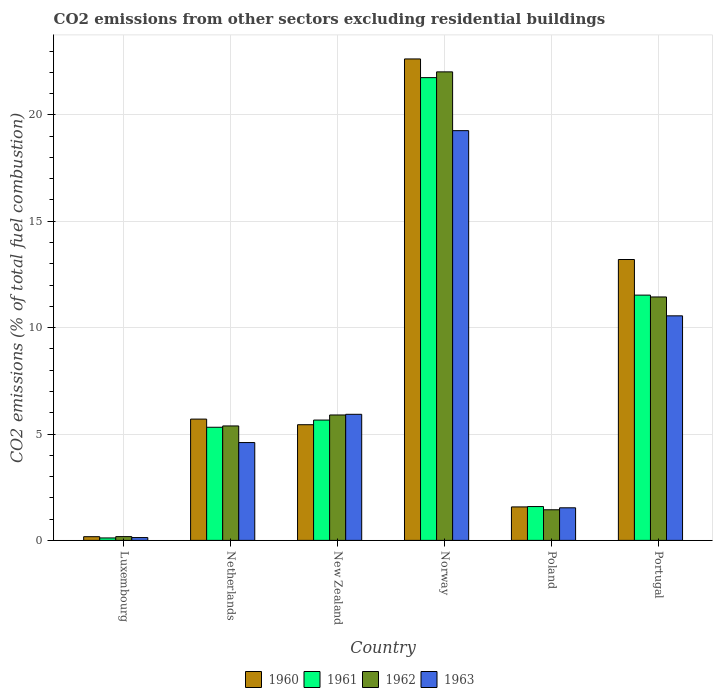How many groups of bars are there?
Keep it short and to the point. 6. Are the number of bars on each tick of the X-axis equal?
Your answer should be very brief. Yes. How many bars are there on the 3rd tick from the left?
Keep it short and to the point. 4. How many bars are there on the 6th tick from the right?
Keep it short and to the point. 4. What is the label of the 2nd group of bars from the left?
Your response must be concise. Netherlands. In how many cases, is the number of bars for a given country not equal to the number of legend labels?
Provide a succinct answer. 0. What is the total CO2 emitted in 1963 in Luxembourg?
Provide a succinct answer. 0.13. Across all countries, what is the maximum total CO2 emitted in 1963?
Provide a succinct answer. 19.26. Across all countries, what is the minimum total CO2 emitted in 1963?
Your response must be concise. 0.13. In which country was the total CO2 emitted in 1963 maximum?
Your answer should be very brief. Norway. In which country was the total CO2 emitted in 1960 minimum?
Offer a terse response. Luxembourg. What is the total total CO2 emitted in 1961 in the graph?
Offer a very short reply. 45.95. What is the difference between the total CO2 emitted in 1963 in New Zealand and that in Norway?
Provide a short and direct response. -13.33. What is the difference between the total CO2 emitted in 1963 in Luxembourg and the total CO2 emitted in 1962 in Poland?
Your response must be concise. -1.31. What is the average total CO2 emitted in 1960 per country?
Give a very brief answer. 8.12. What is the difference between the total CO2 emitted of/in 1962 and total CO2 emitted of/in 1963 in Portugal?
Offer a terse response. 0.89. What is the ratio of the total CO2 emitted in 1963 in Luxembourg to that in New Zealand?
Provide a succinct answer. 0.02. Is the total CO2 emitted in 1962 in Netherlands less than that in Poland?
Your answer should be compact. No. What is the difference between the highest and the second highest total CO2 emitted in 1962?
Provide a succinct answer. 5.55. What is the difference between the highest and the lowest total CO2 emitted in 1962?
Make the answer very short. 21.84. In how many countries, is the total CO2 emitted in 1963 greater than the average total CO2 emitted in 1963 taken over all countries?
Make the answer very short. 2. Is the sum of the total CO2 emitted in 1961 in New Zealand and Poland greater than the maximum total CO2 emitted in 1962 across all countries?
Provide a succinct answer. No. Is it the case that in every country, the sum of the total CO2 emitted in 1963 and total CO2 emitted in 1961 is greater than the sum of total CO2 emitted in 1962 and total CO2 emitted in 1960?
Offer a terse response. No. What does the 1st bar from the left in Poland represents?
Keep it short and to the point. 1960. What does the 2nd bar from the right in New Zealand represents?
Make the answer very short. 1962. What is the difference between two consecutive major ticks on the Y-axis?
Make the answer very short. 5. Are the values on the major ticks of Y-axis written in scientific E-notation?
Your response must be concise. No. Does the graph contain any zero values?
Make the answer very short. No. Does the graph contain grids?
Give a very brief answer. Yes. How many legend labels are there?
Offer a terse response. 4. What is the title of the graph?
Offer a very short reply. CO2 emissions from other sectors excluding residential buildings. Does "1996" appear as one of the legend labels in the graph?
Your answer should be very brief. No. What is the label or title of the X-axis?
Keep it short and to the point. Country. What is the label or title of the Y-axis?
Offer a terse response. CO2 emissions (% of total fuel combustion). What is the CO2 emissions (% of total fuel combustion) in 1960 in Luxembourg?
Your answer should be compact. 0.17. What is the CO2 emissions (% of total fuel combustion) in 1961 in Luxembourg?
Provide a short and direct response. 0.11. What is the CO2 emissions (% of total fuel combustion) in 1962 in Luxembourg?
Make the answer very short. 0.18. What is the CO2 emissions (% of total fuel combustion) in 1963 in Luxembourg?
Your response must be concise. 0.13. What is the CO2 emissions (% of total fuel combustion) of 1960 in Netherlands?
Keep it short and to the point. 5.7. What is the CO2 emissions (% of total fuel combustion) of 1961 in Netherlands?
Keep it short and to the point. 5.32. What is the CO2 emissions (% of total fuel combustion) of 1962 in Netherlands?
Offer a terse response. 5.38. What is the CO2 emissions (% of total fuel combustion) of 1963 in Netherlands?
Your response must be concise. 4.6. What is the CO2 emissions (% of total fuel combustion) of 1960 in New Zealand?
Your answer should be compact. 5.44. What is the CO2 emissions (% of total fuel combustion) of 1961 in New Zealand?
Provide a succinct answer. 5.66. What is the CO2 emissions (% of total fuel combustion) in 1962 in New Zealand?
Your answer should be very brief. 5.89. What is the CO2 emissions (% of total fuel combustion) in 1963 in New Zealand?
Your answer should be very brief. 5.93. What is the CO2 emissions (% of total fuel combustion) of 1960 in Norway?
Offer a very short reply. 22.63. What is the CO2 emissions (% of total fuel combustion) of 1961 in Norway?
Your answer should be very brief. 21.75. What is the CO2 emissions (% of total fuel combustion) in 1962 in Norway?
Provide a succinct answer. 22.02. What is the CO2 emissions (% of total fuel combustion) of 1963 in Norway?
Offer a very short reply. 19.26. What is the CO2 emissions (% of total fuel combustion) of 1960 in Poland?
Ensure brevity in your answer.  1.57. What is the CO2 emissions (% of total fuel combustion) in 1961 in Poland?
Offer a terse response. 1.59. What is the CO2 emissions (% of total fuel combustion) of 1962 in Poland?
Keep it short and to the point. 1.44. What is the CO2 emissions (% of total fuel combustion) in 1963 in Poland?
Provide a short and direct response. 1.53. What is the CO2 emissions (% of total fuel combustion) in 1960 in Portugal?
Offer a very short reply. 13.2. What is the CO2 emissions (% of total fuel combustion) in 1961 in Portugal?
Make the answer very short. 11.53. What is the CO2 emissions (% of total fuel combustion) in 1962 in Portugal?
Your answer should be compact. 11.44. What is the CO2 emissions (% of total fuel combustion) in 1963 in Portugal?
Your response must be concise. 10.55. Across all countries, what is the maximum CO2 emissions (% of total fuel combustion) of 1960?
Keep it short and to the point. 22.63. Across all countries, what is the maximum CO2 emissions (% of total fuel combustion) of 1961?
Offer a very short reply. 21.75. Across all countries, what is the maximum CO2 emissions (% of total fuel combustion) in 1962?
Ensure brevity in your answer.  22.02. Across all countries, what is the maximum CO2 emissions (% of total fuel combustion) in 1963?
Your response must be concise. 19.26. Across all countries, what is the minimum CO2 emissions (% of total fuel combustion) of 1960?
Your answer should be compact. 0.17. Across all countries, what is the minimum CO2 emissions (% of total fuel combustion) of 1961?
Provide a short and direct response. 0.11. Across all countries, what is the minimum CO2 emissions (% of total fuel combustion) of 1962?
Offer a terse response. 0.18. Across all countries, what is the minimum CO2 emissions (% of total fuel combustion) in 1963?
Your answer should be very brief. 0.13. What is the total CO2 emissions (% of total fuel combustion) in 1960 in the graph?
Keep it short and to the point. 48.71. What is the total CO2 emissions (% of total fuel combustion) in 1961 in the graph?
Give a very brief answer. 45.95. What is the total CO2 emissions (% of total fuel combustion) in 1962 in the graph?
Offer a very short reply. 46.35. What is the total CO2 emissions (% of total fuel combustion) of 1963 in the graph?
Offer a terse response. 42. What is the difference between the CO2 emissions (% of total fuel combustion) of 1960 in Luxembourg and that in Netherlands?
Keep it short and to the point. -5.53. What is the difference between the CO2 emissions (% of total fuel combustion) of 1961 in Luxembourg and that in Netherlands?
Provide a short and direct response. -5.2. What is the difference between the CO2 emissions (% of total fuel combustion) of 1962 in Luxembourg and that in Netherlands?
Your answer should be compact. -5.2. What is the difference between the CO2 emissions (% of total fuel combustion) of 1963 in Luxembourg and that in Netherlands?
Keep it short and to the point. -4.47. What is the difference between the CO2 emissions (% of total fuel combustion) in 1960 in Luxembourg and that in New Zealand?
Provide a succinct answer. -5.26. What is the difference between the CO2 emissions (% of total fuel combustion) in 1961 in Luxembourg and that in New Zealand?
Keep it short and to the point. -5.54. What is the difference between the CO2 emissions (% of total fuel combustion) in 1962 in Luxembourg and that in New Zealand?
Your response must be concise. -5.72. What is the difference between the CO2 emissions (% of total fuel combustion) of 1963 in Luxembourg and that in New Zealand?
Give a very brief answer. -5.79. What is the difference between the CO2 emissions (% of total fuel combustion) of 1960 in Luxembourg and that in Norway?
Give a very brief answer. -22.45. What is the difference between the CO2 emissions (% of total fuel combustion) of 1961 in Luxembourg and that in Norway?
Ensure brevity in your answer.  -21.63. What is the difference between the CO2 emissions (% of total fuel combustion) of 1962 in Luxembourg and that in Norway?
Give a very brief answer. -21.84. What is the difference between the CO2 emissions (% of total fuel combustion) of 1963 in Luxembourg and that in Norway?
Ensure brevity in your answer.  -19.12. What is the difference between the CO2 emissions (% of total fuel combustion) in 1960 in Luxembourg and that in Poland?
Offer a terse response. -1.4. What is the difference between the CO2 emissions (% of total fuel combustion) in 1961 in Luxembourg and that in Poland?
Provide a short and direct response. -1.48. What is the difference between the CO2 emissions (% of total fuel combustion) in 1962 in Luxembourg and that in Poland?
Provide a succinct answer. -1.26. What is the difference between the CO2 emissions (% of total fuel combustion) of 1963 in Luxembourg and that in Poland?
Offer a very short reply. -1.4. What is the difference between the CO2 emissions (% of total fuel combustion) of 1960 in Luxembourg and that in Portugal?
Offer a terse response. -13.03. What is the difference between the CO2 emissions (% of total fuel combustion) in 1961 in Luxembourg and that in Portugal?
Give a very brief answer. -11.41. What is the difference between the CO2 emissions (% of total fuel combustion) in 1962 in Luxembourg and that in Portugal?
Your answer should be very brief. -11.26. What is the difference between the CO2 emissions (% of total fuel combustion) of 1963 in Luxembourg and that in Portugal?
Offer a very short reply. -10.42. What is the difference between the CO2 emissions (% of total fuel combustion) of 1960 in Netherlands and that in New Zealand?
Provide a short and direct response. 0.26. What is the difference between the CO2 emissions (% of total fuel combustion) in 1961 in Netherlands and that in New Zealand?
Keep it short and to the point. -0.34. What is the difference between the CO2 emissions (% of total fuel combustion) of 1962 in Netherlands and that in New Zealand?
Offer a very short reply. -0.52. What is the difference between the CO2 emissions (% of total fuel combustion) of 1963 in Netherlands and that in New Zealand?
Give a very brief answer. -1.33. What is the difference between the CO2 emissions (% of total fuel combustion) of 1960 in Netherlands and that in Norway?
Give a very brief answer. -16.93. What is the difference between the CO2 emissions (% of total fuel combustion) in 1961 in Netherlands and that in Norway?
Give a very brief answer. -16.43. What is the difference between the CO2 emissions (% of total fuel combustion) in 1962 in Netherlands and that in Norway?
Give a very brief answer. -16.64. What is the difference between the CO2 emissions (% of total fuel combustion) in 1963 in Netherlands and that in Norway?
Your answer should be compact. -14.66. What is the difference between the CO2 emissions (% of total fuel combustion) in 1960 in Netherlands and that in Poland?
Keep it short and to the point. 4.13. What is the difference between the CO2 emissions (% of total fuel combustion) of 1961 in Netherlands and that in Poland?
Your answer should be very brief. 3.73. What is the difference between the CO2 emissions (% of total fuel combustion) in 1962 in Netherlands and that in Poland?
Keep it short and to the point. 3.94. What is the difference between the CO2 emissions (% of total fuel combustion) in 1963 in Netherlands and that in Poland?
Provide a succinct answer. 3.07. What is the difference between the CO2 emissions (% of total fuel combustion) in 1960 in Netherlands and that in Portugal?
Your response must be concise. -7.5. What is the difference between the CO2 emissions (% of total fuel combustion) in 1961 in Netherlands and that in Portugal?
Keep it short and to the point. -6.21. What is the difference between the CO2 emissions (% of total fuel combustion) in 1962 in Netherlands and that in Portugal?
Make the answer very short. -6.06. What is the difference between the CO2 emissions (% of total fuel combustion) of 1963 in Netherlands and that in Portugal?
Your answer should be very brief. -5.96. What is the difference between the CO2 emissions (% of total fuel combustion) in 1960 in New Zealand and that in Norway?
Your response must be concise. -17.19. What is the difference between the CO2 emissions (% of total fuel combustion) of 1961 in New Zealand and that in Norway?
Ensure brevity in your answer.  -16.09. What is the difference between the CO2 emissions (% of total fuel combustion) of 1962 in New Zealand and that in Norway?
Your answer should be compact. -16.13. What is the difference between the CO2 emissions (% of total fuel combustion) in 1963 in New Zealand and that in Norway?
Your answer should be compact. -13.33. What is the difference between the CO2 emissions (% of total fuel combustion) of 1960 in New Zealand and that in Poland?
Provide a short and direct response. 3.86. What is the difference between the CO2 emissions (% of total fuel combustion) in 1961 in New Zealand and that in Poland?
Make the answer very short. 4.07. What is the difference between the CO2 emissions (% of total fuel combustion) in 1962 in New Zealand and that in Poland?
Provide a succinct answer. 4.45. What is the difference between the CO2 emissions (% of total fuel combustion) in 1963 in New Zealand and that in Poland?
Keep it short and to the point. 4.39. What is the difference between the CO2 emissions (% of total fuel combustion) of 1960 in New Zealand and that in Portugal?
Offer a terse response. -7.76. What is the difference between the CO2 emissions (% of total fuel combustion) of 1961 in New Zealand and that in Portugal?
Your answer should be compact. -5.87. What is the difference between the CO2 emissions (% of total fuel combustion) of 1962 in New Zealand and that in Portugal?
Your answer should be very brief. -5.55. What is the difference between the CO2 emissions (% of total fuel combustion) of 1963 in New Zealand and that in Portugal?
Offer a terse response. -4.63. What is the difference between the CO2 emissions (% of total fuel combustion) in 1960 in Norway and that in Poland?
Your response must be concise. 21.05. What is the difference between the CO2 emissions (% of total fuel combustion) of 1961 in Norway and that in Poland?
Your answer should be very brief. 20.16. What is the difference between the CO2 emissions (% of total fuel combustion) in 1962 in Norway and that in Poland?
Offer a very short reply. 20.58. What is the difference between the CO2 emissions (% of total fuel combustion) of 1963 in Norway and that in Poland?
Provide a succinct answer. 17.73. What is the difference between the CO2 emissions (% of total fuel combustion) of 1960 in Norway and that in Portugal?
Offer a very short reply. 9.43. What is the difference between the CO2 emissions (% of total fuel combustion) of 1961 in Norway and that in Portugal?
Make the answer very short. 10.22. What is the difference between the CO2 emissions (% of total fuel combustion) of 1962 in Norway and that in Portugal?
Provide a short and direct response. 10.58. What is the difference between the CO2 emissions (% of total fuel combustion) of 1963 in Norway and that in Portugal?
Provide a short and direct response. 8.7. What is the difference between the CO2 emissions (% of total fuel combustion) in 1960 in Poland and that in Portugal?
Make the answer very short. -11.63. What is the difference between the CO2 emissions (% of total fuel combustion) of 1961 in Poland and that in Portugal?
Offer a terse response. -9.94. What is the difference between the CO2 emissions (% of total fuel combustion) of 1962 in Poland and that in Portugal?
Give a very brief answer. -10. What is the difference between the CO2 emissions (% of total fuel combustion) in 1963 in Poland and that in Portugal?
Make the answer very short. -9.02. What is the difference between the CO2 emissions (% of total fuel combustion) of 1960 in Luxembourg and the CO2 emissions (% of total fuel combustion) of 1961 in Netherlands?
Your response must be concise. -5.14. What is the difference between the CO2 emissions (% of total fuel combustion) in 1960 in Luxembourg and the CO2 emissions (% of total fuel combustion) in 1962 in Netherlands?
Offer a very short reply. -5.2. What is the difference between the CO2 emissions (% of total fuel combustion) in 1960 in Luxembourg and the CO2 emissions (% of total fuel combustion) in 1963 in Netherlands?
Keep it short and to the point. -4.42. What is the difference between the CO2 emissions (% of total fuel combustion) of 1961 in Luxembourg and the CO2 emissions (% of total fuel combustion) of 1962 in Netherlands?
Ensure brevity in your answer.  -5.26. What is the difference between the CO2 emissions (% of total fuel combustion) in 1961 in Luxembourg and the CO2 emissions (% of total fuel combustion) in 1963 in Netherlands?
Provide a succinct answer. -4.48. What is the difference between the CO2 emissions (% of total fuel combustion) in 1962 in Luxembourg and the CO2 emissions (% of total fuel combustion) in 1963 in Netherlands?
Your answer should be compact. -4.42. What is the difference between the CO2 emissions (% of total fuel combustion) in 1960 in Luxembourg and the CO2 emissions (% of total fuel combustion) in 1961 in New Zealand?
Give a very brief answer. -5.48. What is the difference between the CO2 emissions (% of total fuel combustion) in 1960 in Luxembourg and the CO2 emissions (% of total fuel combustion) in 1962 in New Zealand?
Make the answer very short. -5.72. What is the difference between the CO2 emissions (% of total fuel combustion) of 1960 in Luxembourg and the CO2 emissions (% of total fuel combustion) of 1963 in New Zealand?
Make the answer very short. -5.75. What is the difference between the CO2 emissions (% of total fuel combustion) of 1961 in Luxembourg and the CO2 emissions (% of total fuel combustion) of 1962 in New Zealand?
Provide a succinct answer. -5.78. What is the difference between the CO2 emissions (% of total fuel combustion) of 1961 in Luxembourg and the CO2 emissions (% of total fuel combustion) of 1963 in New Zealand?
Your response must be concise. -5.81. What is the difference between the CO2 emissions (% of total fuel combustion) of 1962 in Luxembourg and the CO2 emissions (% of total fuel combustion) of 1963 in New Zealand?
Offer a terse response. -5.75. What is the difference between the CO2 emissions (% of total fuel combustion) in 1960 in Luxembourg and the CO2 emissions (% of total fuel combustion) in 1961 in Norway?
Provide a short and direct response. -21.58. What is the difference between the CO2 emissions (% of total fuel combustion) of 1960 in Luxembourg and the CO2 emissions (% of total fuel combustion) of 1962 in Norway?
Ensure brevity in your answer.  -21.85. What is the difference between the CO2 emissions (% of total fuel combustion) of 1960 in Luxembourg and the CO2 emissions (% of total fuel combustion) of 1963 in Norway?
Your answer should be very brief. -19.08. What is the difference between the CO2 emissions (% of total fuel combustion) in 1961 in Luxembourg and the CO2 emissions (% of total fuel combustion) in 1962 in Norway?
Offer a terse response. -21.91. What is the difference between the CO2 emissions (% of total fuel combustion) of 1961 in Luxembourg and the CO2 emissions (% of total fuel combustion) of 1963 in Norway?
Give a very brief answer. -19.14. What is the difference between the CO2 emissions (% of total fuel combustion) in 1962 in Luxembourg and the CO2 emissions (% of total fuel combustion) in 1963 in Norway?
Make the answer very short. -19.08. What is the difference between the CO2 emissions (% of total fuel combustion) of 1960 in Luxembourg and the CO2 emissions (% of total fuel combustion) of 1961 in Poland?
Offer a very short reply. -1.42. What is the difference between the CO2 emissions (% of total fuel combustion) of 1960 in Luxembourg and the CO2 emissions (% of total fuel combustion) of 1962 in Poland?
Make the answer very short. -1.27. What is the difference between the CO2 emissions (% of total fuel combustion) of 1960 in Luxembourg and the CO2 emissions (% of total fuel combustion) of 1963 in Poland?
Provide a short and direct response. -1.36. What is the difference between the CO2 emissions (% of total fuel combustion) of 1961 in Luxembourg and the CO2 emissions (% of total fuel combustion) of 1962 in Poland?
Make the answer very short. -1.32. What is the difference between the CO2 emissions (% of total fuel combustion) in 1961 in Luxembourg and the CO2 emissions (% of total fuel combustion) in 1963 in Poland?
Provide a succinct answer. -1.42. What is the difference between the CO2 emissions (% of total fuel combustion) in 1962 in Luxembourg and the CO2 emissions (% of total fuel combustion) in 1963 in Poland?
Offer a terse response. -1.35. What is the difference between the CO2 emissions (% of total fuel combustion) of 1960 in Luxembourg and the CO2 emissions (% of total fuel combustion) of 1961 in Portugal?
Keep it short and to the point. -11.35. What is the difference between the CO2 emissions (% of total fuel combustion) of 1960 in Luxembourg and the CO2 emissions (% of total fuel combustion) of 1962 in Portugal?
Your answer should be very brief. -11.27. What is the difference between the CO2 emissions (% of total fuel combustion) in 1960 in Luxembourg and the CO2 emissions (% of total fuel combustion) in 1963 in Portugal?
Provide a succinct answer. -10.38. What is the difference between the CO2 emissions (% of total fuel combustion) of 1961 in Luxembourg and the CO2 emissions (% of total fuel combustion) of 1962 in Portugal?
Offer a terse response. -11.33. What is the difference between the CO2 emissions (% of total fuel combustion) in 1961 in Luxembourg and the CO2 emissions (% of total fuel combustion) in 1963 in Portugal?
Your answer should be compact. -10.44. What is the difference between the CO2 emissions (% of total fuel combustion) in 1962 in Luxembourg and the CO2 emissions (% of total fuel combustion) in 1963 in Portugal?
Keep it short and to the point. -10.38. What is the difference between the CO2 emissions (% of total fuel combustion) of 1960 in Netherlands and the CO2 emissions (% of total fuel combustion) of 1961 in New Zealand?
Keep it short and to the point. 0.05. What is the difference between the CO2 emissions (% of total fuel combustion) in 1960 in Netherlands and the CO2 emissions (% of total fuel combustion) in 1962 in New Zealand?
Offer a very short reply. -0.19. What is the difference between the CO2 emissions (% of total fuel combustion) in 1960 in Netherlands and the CO2 emissions (% of total fuel combustion) in 1963 in New Zealand?
Ensure brevity in your answer.  -0.23. What is the difference between the CO2 emissions (% of total fuel combustion) of 1961 in Netherlands and the CO2 emissions (% of total fuel combustion) of 1962 in New Zealand?
Provide a succinct answer. -0.58. What is the difference between the CO2 emissions (% of total fuel combustion) in 1961 in Netherlands and the CO2 emissions (% of total fuel combustion) in 1963 in New Zealand?
Give a very brief answer. -0.61. What is the difference between the CO2 emissions (% of total fuel combustion) in 1962 in Netherlands and the CO2 emissions (% of total fuel combustion) in 1963 in New Zealand?
Offer a terse response. -0.55. What is the difference between the CO2 emissions (% of total fuel combustion) of 1960 in Netherlands and the CO2 emissions (% of total fuel combustion) of 1961 in Norway?
Your response must be concise. -16.05. What is the difference between the CO2 emissions (% of total fuel combustion) of 1960 in Netherlands and the CO2 emissions (% of total fuel combustion) of 1962 in Norway?
Give a very brief answer. -16.32. What is the difference between the CO2 emissions (% of total fuel combustion) of 1960 in Netherlands and the CO2 emissions (% of total fuel combustion) of 1963 in Norway?
Your response must be concise. -13.56. What is the difference between the CO2 emissions (% of total fuel combustion) in 1961 in Netherlands and the CO2 emissions (% of total fuel combustion) in 1962 in Norway?
Your answer should be compact. -16.7. What is the difference between the CO2 emissions (% of total fuel combustion) in 1961 in Netherlands and the CO2 emissions (% of total fuel combustion) in 1963 in Norway?
Make the answer very short. -13.94. What is the difference between the CO2 emissions (% of total fuel combustion) in 1962 in Netherlands and the CO2 emissions (% of total fuel combustion) in 1963 in Norway?
Provide a short and direct response. -13.88. What is the difference between the CO2 emissions (% of total fuel combustion) in 1960 in Netherlands and the CO2 emissions (% of total fuel combustion) in 1961 in Poland?
Offer a very short reply. 4.11. What is the difference between the CO2 emissions (% of total fuel combustion) in 1960 in Netherlands and the CO2 emissions (% of total fuel combustion) in 1962 in Poland?
Ensure brevity in your answer.  4.26. What is the difference between the CO2 emissions (% of total fuel combustion) in 1960 in Netherlands and the CO2 emissions (% of total fuel combustion) in 1963 in Poland?
Provide a short and direct response. 4.17. What is the difference between the CO2 emissions (% of total fuel combustion) in 1961 in Netherlands and the CO2 emissions (% of total fuel combustion) in 1962 in Poland?
Offer a terse response. 3.88. What is the difference between the CO2 emissions (% of total fuel combustion) in 1961 in Netherlands and the CO2 emissions (% of total fuel combustion) in 1963 in Poland?
Keep it short and to the point. 3.79. What is the difference between the CO2 emissions (% of total fuel combustion) in 1962 in Netherlands and the CO2 emissions (% of total fuel combustion) in 1963 in Poland?
Your response must be concise. 3.85. What is the difference between the CO2 emissions (% of total fuel combustion) of 1960 in Netherlands and the CO2 emissions (% of total fuel combustion) of 1961 in Portugal?
Keep it short and to the point. -5.83. What is the difference between the CO2 emissions (% of total fuel combustion) of 1960 in Netherlands and the CO2 emissions (% of total fuel combustion) of 1962 in Portugal?
Your response must be concise. -5.74. What is the difference between the CO2 emissions (% of total fuel combustion) of 1960 in Netherlands and the CO2 emissions (% of total fuel combustion) of 1963 in Portugal?
Your answer should be very brief. -4.85. What is the difference between the CO2 emissions (% of total fuel combustion) of 1961 in Netherlands and the CO2 emissions (% of total fuel combustion) of 1962 in Portugal?
Your response must be concise. -6.12. What is the difference between the CO2 emissions (% of total fuel combustion) in 1961 in Netherlands and the CO2 emissions (% of total fuel combustion) in 1963 in Portugal?
Offer a terse response. -5.24. What is the difference between the CO2 emissions (% of total fuel combustion) of 1962 in Netherlands and the CO2 emissions (% of total fuel combustion) of 1963 in Portugal?
Make the answer very short. -5.17. What is the difference between the CO2 emissions (% of total fuel combustion) of 1960 in New Zealand and the CO2 emissions (% of total fuel combustion) of 1961 in Norway?
Offer a very short reply. -16.31. What is the difference between the CO2 emissions (% of total fuel combustion) in 1960 in New Zealand and the CO2 emissions (% of total fuel combustion) in 1962 in Norway?
Offer a very short reply. -16.58. What is the difference between the CO2 emissions (% of total fuel combustion) of 1960 in New Zealand and the CO2 emissions (% of total fuel combustion) of 1963 in Norway?
Keep it short and to the point. -13.82. What is the difference between the CO2 emissions (% of total fuel combustion) of 1961 in New Zealand and the CO2 emissions (% of total fuel combustion) of 1962 in Norway?
Make the answer very short. -16.36. What is the difference between the CO2 emissions (% of total fuel combustion) in 1961 in New Zealand and the CO2 emissions (% of total fuel combustion) in 1963 in Norway?
Offer a terse response. -13.6. What is the difference between the CO2 emissions (% of total fuel combustion) in 1962 in New Zealand and the CO2 emissions (% of total fuel combustion) in 1963 in Norway?
Provide a succinct answer. -13.36. What is the difference between the CO2 emissions (% of total fuel combustion) of 1960 in New Zealand and the CO2 emissions (% of total fuel combustion) of 1961 in Poland?
Your response must be concise. 3.85. What is the difference between the CO2 emissions (% of total fuel combustion) in 1960 in New Zealand and the CO2 emissions (% of total fuel combustion) in 1962 in Poland?
Provide a short and direct response. 4. What is the difference between the CO2 emissions (% of total fuel combustion) of 1960 in New Zealand and the CO2 emissions (% of total fuel combustion) of 1963 in Poland?
Keep it short and to the point. 3.91. What is the difference between the CO2 emissions (% of total fuel combustion) in 1961 in New Zealand and the CO2 emissions (% of total fuel combustion) in 1962 in Poland?
Provide a short and direct response. 4.22. What is the difference between the CO2 emissions (% of total fuel combustion) in 1961 in New Zealand and the CO2 emissions (% of total fuel combustion) in 1963 in Poland?
Offer a very short reply. 4.12. What is the difference between the CO2 emissions (% of total fuel combustion) in 1962 in New Zealand and the CO2 emissions (% of total fuel combustion) in 1963 in Poland?
Offer a very short reply. 4.36. What is the difference between the CO2 emissions (% of total fuel combustion) of 1960 in New Zealand and the CO2 emissions (% of total fuel combustion) of 1961 in Portugal?
Keep it short and to the point. -6.09. What is the difference between the CO2 emissions (% of total fuel combustion) in 1960 in New Zealand and the CO2 emissions (% of total fuel combustion) in 1962 in Portugal?
Your response must be concise. -6. What is the difference between the CO2 emissions (% of total fuel combustion) of 1960 in New Zealand and the CO2 emissions (% of total fuel combustion) of 1963 in Portugal?
Your answer should be very brief. -5.12. What is the difference between the CO2 emissions (% of total fuel combustion) of 1961 in New Zealand and the CO2 emissions (% of total fuel combustion) of 1962 in Portugal?
Keep it short and to the point. -5.79. What is the difference between the CO2 emissions (% of total fuel combustion) in 1961 in New Zealand and the CO2 emissions (% of total fuel combustion) in 1963 in Portugal?
Your answer should be very brief. -4.9. What is the difference between the CO2 emissions (% of total fuel combustion) of 1962 in New Zealand and the CO2 emissions (% of total fuel combustion) of 1963 in Portugal?
Your answer should be compact. -4.66. What is the difference between the CO2 emissions (% of total fuel combustion) in 1960 in Norway and the CO2 emissions (% of total fuel combustion) in 1961 in Poland?
Offer a very short reply. 21.04. What is the difference between the CO2 emissions (% of total fuel combustion) of 1960 in Norway and the CO2 emissions (% of total fuel combustion) of 1962 in Poland?
Your answer should be very brief. 21.19. What is the difference between the CO2 emissions (% of total fuel combustion) in 1960 in Norway and the CO2 emissions (% of total fuel combustion) in 1963 in Poland?
Your answer should be compact. 21.1. What is the difference between the CO2 emissions (% of total fuel combustion) of 1961 in Norway and the CO2 emissions (% of total fuel combustion) of 1962 in Poland?
Your answer should be compact. 20.31. What is the difference between the CO2 emissions (% of total fuel combustion) in 1961 in Norway and the CO2 emissions (% of total fuel combustion) in 1963 in Poland?
Your answer should be compact. 20.22. What is the difference between the CO2 emissions (% of total fuel combustion) in 1962 in Norway and the CO2 emissions (% of total fuel combustion) in 1963 in Poland?
Offer a terse response. 20.49. What is the difference between the CO2 emissions (% of total fuel combustion) in 1960 in Norway and the CO2 emissions (% of total fuel combustion) in 1961 in Portugal?
Make the answer very short. 11.1. What is the difference between the CO2 emissions (% of total fuel combustion) in 1960 in Norway and the CO2 emissions (% of total fuel combustion) in 1962 in Portugal?
Give a very brief answer. 11.19. What is the difference between the CO2 emissions (% of total fuel combustion) in 1960 in Norway and the CO2 emissions (% of total fuel combustion) in 1963 in Portugal?
Your answer should be compact. 12.07. What is the difference between the CO2 emissions (% of total fuel combustion) of 1961 in Norway and the CO2 emissions (% of total fuel combustion) of 1962 in Portugal?
Your answer should be very brief. 10.31. What is the difference between the CO2 emissions (% of total fuel combustion) of 1961 in Norway and the CO2 emissions (% of total fuel combustion) of 1963 in Portugal?
Your answer should be very brief. 11.2. What is the difference between the CO2 emissions (% of total fuel combustion) in 1962 in Norway and the CO2 emissions (% of total fuel combustion) in 1963 in Portugal?
Make the answer very short. 11.47. What is the difference between the CO2 emissions (% of total fuel combustion) of 1960 in Poland and the CO2 emissions (% of total fuel combustion) of 1961 in Portugal?
Your answer should be compact. -9.95. What is the difference between the CO2 emissions (% of total fuel combustion) of 1960 in Poland and the CO2 emissions (% of total fuel combustion) of 1962 in Portugal?
Provide a succinct answer. -9.87. What is the difference between the CO2 emissions (% of total fuel combustion) of 1960 in Poland and the CO2 emissions (% of total fuel combustion) of 1963 in Portugal?
Provide a succinct answer. -8.98. What is the difference between the CO2 emissions (% of total fuel combustion) in 1961 in Poland and the CO2 emissions (% of total fuel combustion) in 1962 in Portugal?
Offer a terse response. -9.85. What is the difference between the CO2 emissions (% of total fuel combustion) in 1961 in Poland and the CO2 emissions (% of total fuel combustion) in 1963 in Portugal?
Give a very brief answer. -8.96. What is the difference between the CO2 emissions (% of total fuel combustion) in 1962 in Poland and the CO2 emissions (% of total fuel combustion) in 1963 in Portugal?
Ensure brevity in your answer.  -9.11. What is the average CO2 emissions (% of total fuel combustion) of 1960 per country?
Ensure brevity in your answer.  8.12. What is the average CO2 emissions (% of total fuel combustion) in 1961 per country?
Ensure brevity in your answer.  7.66. What is the average CO2 emissions (% of total fuel combustion) in 1962 per country?
Your answer should be very brief. 7.72. What is the average CO2 emissions (% of total fuel combustion) in 1963 per country?
Ensure brevity in your answer.  7. What is the difference between the CO2 emissions (% of total fuel combustion) of 1960 and CO2 emissions (% of total fuel combustion) of 1961 in Luxembourg?
Your answer should be very brief. 0.06. What is the difference between the CO2 emissions (% of total fuel combustion) in 1960 and CO2 emissions (% of total fuel combustion) in 1962 in Luxembourg?
Ensure brevity in your answer.  -0. What is the difference between the CO2 emissions (% of total fuel combustion) of 1960 and CO2 emissions (% of total fuel combustion) of 1963 in Luxembourg?
Offer a terse response. 0.04. What is the difference between the CO2 emissions (% of total fuel combustion) of 1961 and CO2 emissions (% of total fuel combustion) of 1962 in Luxembourg?
Offer a very short reply. -0.06. What is the difference between the CO2 emissions (% of total fuel combustion) of 1961 and CO2 emissions (% of total fuel combustion) of 1963 in Luxembourg?
Your answer should be compact. -0.02. What is the difference between the CO2 emissions (% of total fuel combustion) of 1962 and CO2 emissions (% of total fuel combustion) of 1963 in Luxembourg?
Offer a very short reply. 0.04. What is the difference between the CO2 emissions (% of total fuel combustion) of 1960 and CO2 emissions (% of total fuel combustion) of 1961 in Netherlands?
Your answer should be compact. 0.38. What is the difference between the CO2 emissions (% of total fuel combustion) in 1960 and CO2 emissions (% of total fuel combustion) in 1962 in Netherlands?
Offer a very short reply. 0.32. What is the difference between the CO2 emissions (% of total fuel combustion) in 1960 and CO2 emissions (% of total fuel combustion) in 1963 in Netherlands?
Offer a terse response. 1.1. What is the difference between the CO2 emissions (% of total fuel combustion) in 1961 and CO2 emissions (% of total fuel combustion) in 1962 in Netherlands?
Your answer should be compact. -0.06. What is the difference between the CO2 emissions (% of total fuel combustion) in 1961 and CO2 emissions (% of total fuel combustion) in 1963 in Netherlands?
Your answer should be very brief. 0.72. What is the difference between the CO2 emissions (% of total fuel combustion) in 1962 and CO2 emissions (% of total fuel combustion) in 1963 in Netherlands?
Offer a terse response. 0.78. What is the difference between the CO2 emissions (% of total fuel combustion) in 1960 and CO2 emissions (% of total fuel combustion) in 1961 in New Zealand?
Provide a short and direct response. -0.22. What is the difference between the CO2 emissions (% of total fuel combustion) of 1960 and CO2 emissions (% of total fuel combustion) of 1962 in New Zealand?
Offer a very short reply. -0.46. What is the difference between the CO2 emissions (% of total fuel combustion) of 1960 and CO2 emissions (% of total fuel combustion) of 1963 in New Zealand?
Provide a short and direct response. -0.49. What is the difference between the CO2 emissions (% of total fuel combustion) of 1961 and CO2 emissions (% of total fuel combustion) of 1962 in New Zealand?
Provide a short and direct response. -0.24. What is the difference between the CO2 emissions (% of total fuel combustion) in 1961 and CO2 emissions (% of total fuel combustion) in 1963 in New Zealand?
Offer a very short reply. -0.27. What is the difference between the CO2 emissions (% of total fuel combustion) in 1962 and CO2 emissions (% of total fuel combustion) in 1963 in New Zealand?
Provide a succinct answer. -0.03. What is the difference between the CO2 emissions (% of total fuel combustion) of 1960 and CO2 emissions (% of total fuel combustion) of 1961 in Norway?
Your response must be concise. 0.88. What is the difference between the CO2 emissions (% of total fuel combustion) of 1960 and CO2 emissions (% of total fuel combustion) of 1962 in Norway?
Your answer should be compact. 0.61. What is the difference between the CO2 emissions (% of total fuel combustion) of 1960 and CO2 emissions (% of total fuel combustion) of 1963 in Norway?
Make the answer very short. 3.37. What is the difference between the CO2 emissions (% of total fuel combustion) in 1961 and CO2 emissions (% of total fuel combustion) in 1962 in Norway?
Ensure brevity in your answer.  -0.27. What is the difference between the CO2 emissions (% of total fuel combustion) in 1961 and CO2 emissions (% of total fuel combustion) in 1963 in Norway?
Offer a terse response. 2.49. What is the difference between the CO2 emissions (% of total fuel combustion) in 1962 and CO2 emissions (% of total fuel combustion) in 1963 in Norway?
Your response must be concise. 2.76. What is the difference between the CO2 emissions (% of total fuel combustion) of 1960 and CO2 emissions (% of total fuel combustion) of 1961 in Poland?
Provide a succinct answer. -0.02. What is the difference between the CO2 emissions (% of total fuel combustion) of 1960 and CO2 emissions (% of total fuel combustion) of 1962 in Poland?
Provide a succinct answer. 0.13. What is the difference between the CO2 emissions (% of total fuel combustion) of 1960 and CO2 emissions (% of total fuel combustion) of 1963 in Poland?
Offer a very short reply. 0.04. What is the difference between the CO2 emissions (% of total fuel combustion) of 1961 and CO2 emissions (% of total fuel combustion) of 1962 in Poland?
Provide a short and direct response. 0.15. What is the difference between the CO2 emissions (% of total fuel combustion) of 1961 and CO2 emissions (% of total fuel combustion) of 1963 in Poland?
Make the answer very short. 0.06. What is the difference between the CO2 emissions (% of total fuel combustion) in 1962 and CO2 emissions (% of total fuel combustion) in 1963 in Poland?
Ensure brevity in your answer.  -0.09. What is the difference between the CO2 emissions (% of total fuel combustion) of 1960 and CO2 emissions (% of total fuel combustion) of 1961 in Portugal?
Provide a short and direct response. 1.67. What is the difference between the CO2 emissions (% of total fuel combustion) of 1960 and CO2 emissions (% of total fuel combustion) of 1962 in Portugal?
Offer a terse response. 1.76. What is the difference between the CO2 emissions (% of total fuel combustion) of 1960 and CO2 emissions (% of total fuel combustion) of 1963 in Portugal?
Offer a terse response. 2.65. What is the difference between the CO2 emissions (% of total fuel combustion) of 1961 and CO2 emissions (% of total fuel combustion) of 1962 in Portugal?
Your answer should be very brief. 0.09. What is the difference between the CO2 emissions (% of total fuel combustion) of 1961 and CO2 emissions (% of total fuel combustion) of 1963 in Portugal?
Provide a succinct answer. 0.97. What is the difference between the CO2 emissions (% of total fuel combustion) in 1962 and CO2 emissions (% of total fuel combustion) in 1963 in Portugal?
Give a very brief answer. 0.89. What is the ratio of the CO2 emissions (% of total fuel combustion) of 1960 in Luxembourg to that in Netherlands?
Provide a short and direct response. 0.03. What is the ratio of the CO2 emissions (% of total fuel combustion) of 1961 in Luxembourg to that in Netherlands?
Ensure brevity in your answer.  0.02. What is the ratio of the CO2 emissions (% of total fuel combustion) in 1962 in Luxembourg to that in Netherlands?
Provide a short and direct response. 0.03. What is the ratio of the CO2 emissions (% of total fuel combustion) in 1963 in Luxembourg to that in Netherlands?
Your response must be concise. 0.03. What is the ratio of the CO2 emissions (% of total fuel combustion) in 1960 in Luxembourg to that in New Zealand?
Ensure brevity in your answer.  0.03. What is the ratio of the CO2 emissions (% of total fuel combustion) in 1961 in Luxembourg to that in New Zealand?
Offer a very short reply. 0.02. What is the ratio of the CO2 emissions (% of total fuel combustion) in 1963 in Luxembourg to that in New Zealand?
Offer a very short reply. 0.02. What is the ratio of the CO2 emissions (% of total fuel combustion) in 1960 in Luxembourg to that in Norway?
Provide a succinct answer. 0.01. What is the ratio of the CO2 emissions (% of total fuel combustion) of 1961 in Luxembourg to that in Norway?
Your answer should be compact. 0.01. What is the ratio of the CO2 emissions (% of total fuel combustion) of 1962 in Luxembourg to that in Norway?
Offer a very short reply. 0.01. What is the ratio of the CO2 emissions (% of total fuel combustion) in 1963 in Luxembourg to that in Norway?
Offer a very short reply. 0.01. What is the ratio of the CO2 emissions (% of total fuel combustion) of 1960 in Luxembourg to that in Poland?
Make the answer very short. 0.11. What is the ratio of the CO2 emissions (% of total fuel combustion) in 1961 in Luxembourg to that in Poland?
Provide a short and direct response. 0.07. What is the ratio of the CO2 emissions (% of total fuel combustion) in 1962 in Luxembourg to that in Poland?
Provide a short and direct response. 0.12. What is the ratio of the CO2 emissions (% of total fuel combustion) of 1963 in Luxembourg to that in Poland?
Offer a very short reply. 0.09. What is the ratio of the CO2 emissions (% of total fuel combustion) of 1960 in Luxembourg to that in Portugal?
Give a very brief answer. 0.01. What is the ratio of the CO2 emissions (% of total fuel combustion) of 1961 in Luxembourg to that in Portugal?
Give a very brief answer. 0.01. What is the ratio of the CO2 emissions (% of total fuel combustion) of 1962 in Luxembourg to that in Portugal?
Your answer should be very brief. 0.02. What is the ratio of the CO2 emissions (% of total fuel combustion) of 1963 in Luxembourg to that in Portugal?
Give a very brief answer. 0.01. What is the ratio of the CO2 emissions (% of total fuel combustion) of 1960 in Netherlands to that in New Zealand?
Give a very brief answer. 1.05. What is the ratio of the CO2 emissions (% of total fuel combustion) of 1961 in Netherlands to that in New Zealand?
Your answer should be compact. 0.94. What is the ratio of the CO2 emissions (% of total fuel combustion) in 1962 in Netherlands to that in New Zealand?
Keep it short and to the point. 0.91. What is the ratio of the CO2 emissions (% of total fuel combustion) in 1963 in Netherlands to that in New Zealand?
Ensure brevity in your answer.  0.78. What is the ratio of the CO2 emissions (% of total fuel combustion) of 1960 in Netherlands to that in Norway?
Your answer should be very brief. 0.25. What is the ratio of the CO2 emissions (% of total fuel combustion) of 1961 in Netherlands to that in Norway?
Give a very brief answer. 0.24. What is the ratio of the CO2 emissions (% of total fuel combustion) of 1962 in Netherlands to that in Norway?
Offer a terse response. 0.24. What is the ratio of the CO2 emissions (% of total fuel combustion) in 1963 in Netherlands to that in Norway?
Keep it short and to the point. 0.24. What is the ratio of the CO2 emissions (% of total fuel combustion) of 1960 in Netherlands to that in Poland?
Make the answer very short. 3.62. What is the ratio of the CO2 emissions (% of total fuel combustion) of 1961 in Netherlands to that in Poland?
Ensure brevity in your answer.  3.34. What is the ratio of the CO2 emissions (% of total fuel combustion) of 1962 in Netherlands to that in Poland?
Offer a terse response. 3.74. What is the ratio of the CO2 emissions (% of total fuel combustion) of 1963 in Netherlands to that in Poland?
Your answer should be compact. 3. What is the ratio of the CO2 emissions (% of total fuel combustion) in 1960 in Netherlands to that in Portugal?
Keep it short and to the point. 0.43. What is the ratio of the CO2 emissions (% of total fuel combustion) in 1961 in Netherlands to that in Portugal?
Offer a terse response. 0.46. What is the ratio of the CO2 emissions (% of total fuel combustion) in 1962 in Netherlands to that in Portugal?
Give a very brief answer. 0.47. What is the ratio of the CO2 emissions (% of total fuel combustion) of 1963 in Netherlands to that in Portugal?
Ensure brevity in your answer.  0.44. What is the ratio of the CO2 emissions (% of total fuel combustion) in 1960 in New Zealand to that in Norway?
Make the answer very short. 0.24. What is the ratio of the CO2 emissions (% of total fuel combustion) of 1961 in New Zealand to that in Norway?
Ensure brevity in your answer.  0.26. What is the ratio of the CO2 emissions (% of total fuel combustion) of 1962 in New Zealand to that in Norway?
Give a very brief answer. 0.27. What is the ratio of the CO2 emissions (% of total fuel combustion) of 1963 in New Zealand to that in Norway?
Your answer should be very brief. 0.31. What is the ratio of the CO2 emissions (% of total fuel combustion) in 1960 in New Zealand to that in Poland?
Offer a terse response. 3.46. What is the ratio of the CO2 emissions (% of total fuel combustion) in 1961 in New Zealand to that in Poland?
Provide a succinct answer. 3.56. What is the ratio of the CO2 emissions (% of total fuel combustion) in 1962 in New Zealand to that in Poland?
Make the answer very short. 4.1. What is the ratio of the CO2 emissions (% of total fuel combustion) in 1963 in New Zealand to that in Poland?
Give a very brief answer. 3.87. What is the ratio of the CO2 emissions (% of total fuel combustion) in 1960 in New Zealand to that in Portugal?
Provide a succinct answer. 0.41. What is the ratio of the CO2 emissions (% of total fuel combustion) of 1961 in New Zealand to that in Portugal?
Provide a succinct answer. 0.49. What is the ratio of the CO2 emissions (% of total fuel combustion) in 1962 in New Zealand to that in Portugal?
Your answer should be compact. 0.52. What is the ratio of the CO2 emissions (% of total fuel combustion) of 1963 in New Zealand to that in Portugal?
Provide a short and direct response. 0.56. What is the ratio of the CO2 emissions (% of total fuel combustion) in 1960 in Norway to that in Poland?
Keep it short and to the point. 14.38. What is the ratio of the CO2 emissions (% of total fuel combustion) in 1961 in Norway to that in Poland?
Offer a terse response. 13.68. What is the ratio of the CO2 emissions (% of total fuel combustion) in 1962 in Norway to that in Poland?
Your answer should be very brief. 15.3. What is the ratio of the CO2 emissions (% of total fuel combustion) of 1963 in Norway to that in Poland?
Ensure brevity in your answer.  12.57. What is the ratio of the CO2 emissions (% of total fuel combustion) of 1960 in Norway to that in Portugal?
Ensure brevity in your answer.  1.71. What is the ratio of the CO2 emissions (% of total fuel combustion) in 1961 in Norway to that in Portugal?
Provide a short and direct response. 1.89. What is the ratio of the CO2 emissions (% of total fuel combustion) of 1962 in Norway to that in Portugal?
Your answer should be compact. 1.92. What is the ratio of the CO2 emissions (% of total fuel combustion) in 1963 in Norway to that in Portugal?
Give a very brief answer. 1.82. What is the ratio of the CO2 emissions (% of total fuel combustion) of 1960 in Poland to that in Portugal?
Provide a succinct answer. 0.12. What is the ratio of the CO2 emissions (% of total fuel combustion) in 1961 in Poland to that in Portugal?
Ensure brevity in your answer.  0.14. What is the ratio of the CO2 emissions (% of total fuel combustion) in 1962 in Poland to that in Portugal?
Make the answer very short. 0.13. What is the ratio of the CO2 emissions (% of total fuel combustion) of 1963 in Poland to that in Portugal?
Offer a very short reply. 0.15. What is the difference between the highest and the second highest CO2 emissions (% of total fuel combustion) of 1960?
Provide a succinct answer. 9.43. What is the difference between the highest and the second highest CO2 emissions (% of total fuel combustion) of 1961?
Provide a succinct answer. 10.22. What is the difference between the highest and the second highest CO2 emissions (% of total fuel combustion) in 1962?
Your response must be concise. 10.58. What is the difference between the highest and the second highest CO2 emissions (% of total fuel combustion) of 1963?
Offer a terse response. 8.7. What is the difference between the highest and the lowest CO2 emissions (% of total fuel combustion) in 1960?
Offer a very short reply. 22.45. What is the difference between the highest and the lowest CO2 emissions (% of total fuel combustion) in 1961?
Ensure brevity in your answer.  21.63. What is the difference between the highest and the lowest CO2 emissions (% of total fuel combustion) in 1962?
Make the answer very short. 21.84. What is the difference between the highest and the lowest CO2 emissions (% of total fuel combustion) in 1963?
Offer a very short reply. 19.12. 